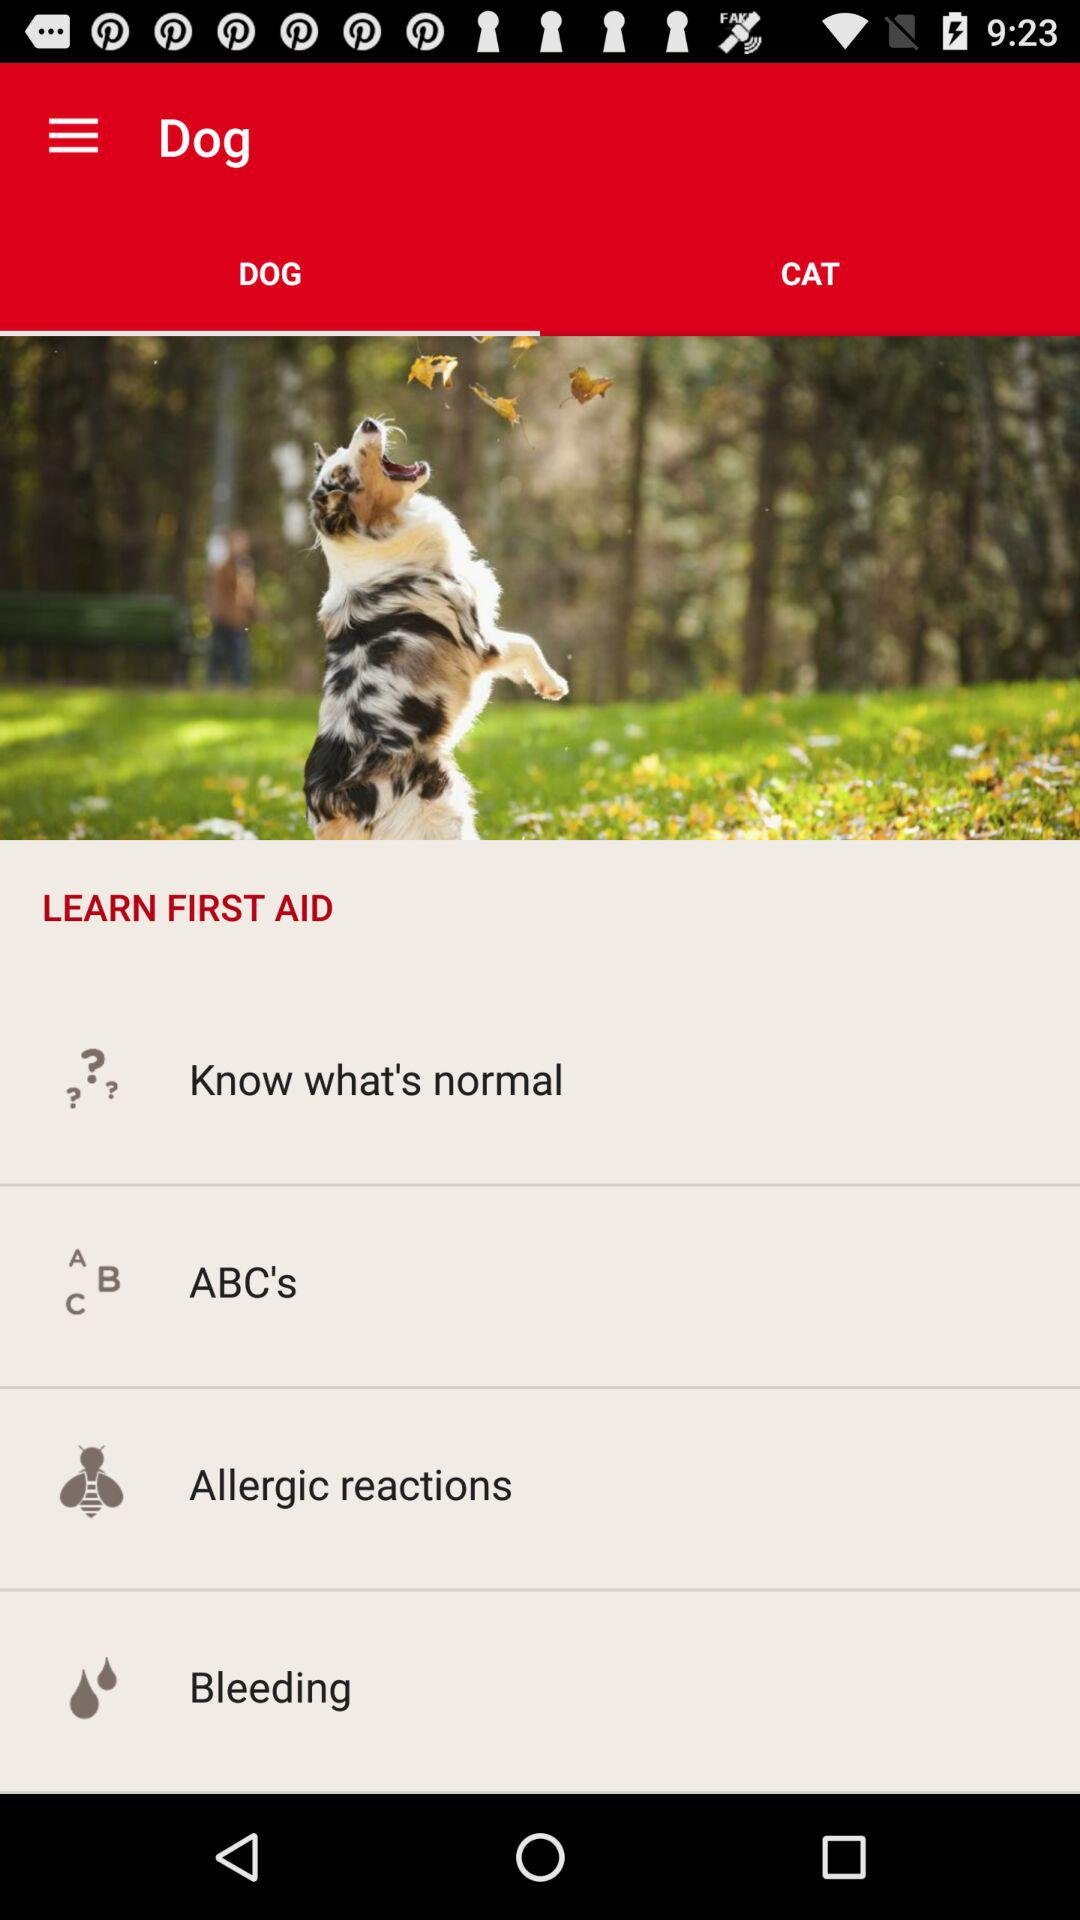For which animal is the person taking the information? The person is taking information for a dog. 